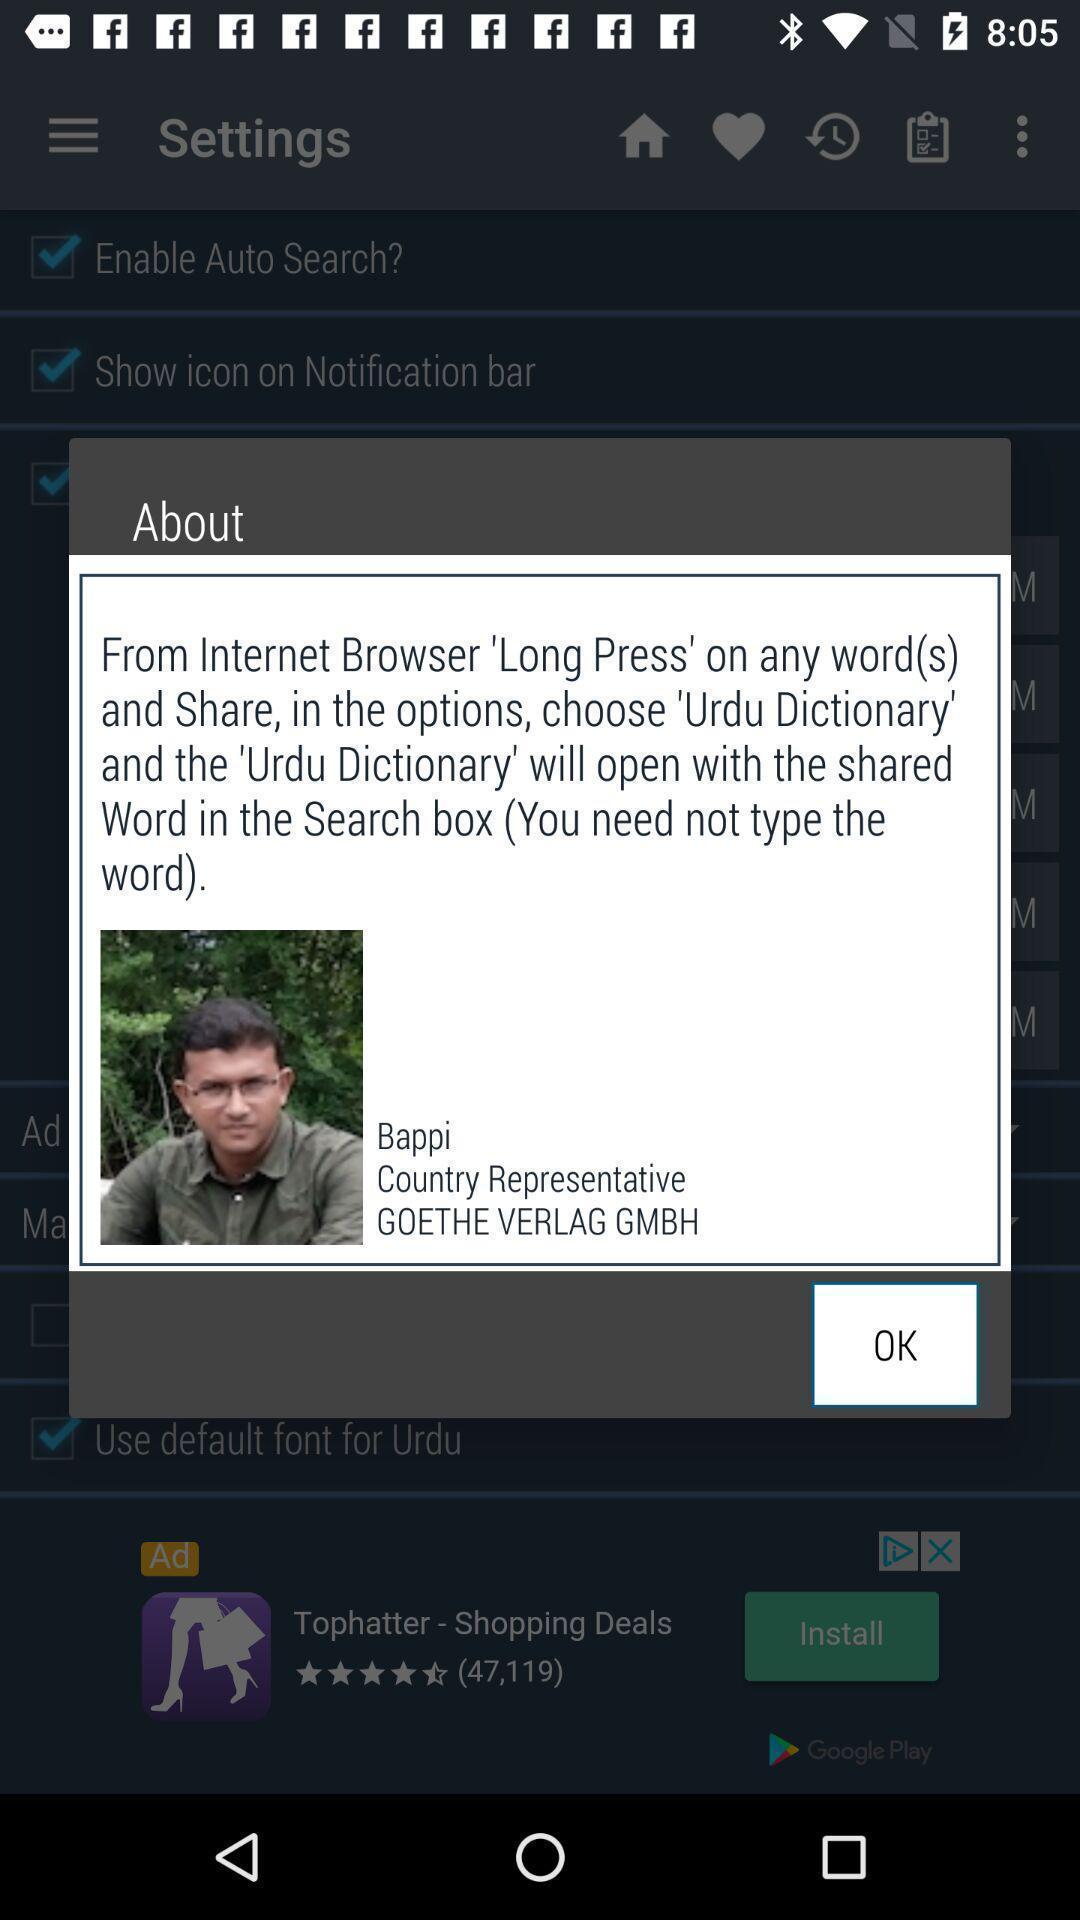Tell me about the visual elements in this screen capture. Push up message with information about the app. 